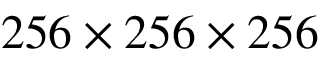Convert formula to latex. <formula><loc_0><loc_0><loc_500><loc_500>2 5 6 \times 2 5 6 \times 2 5 6</formula> 